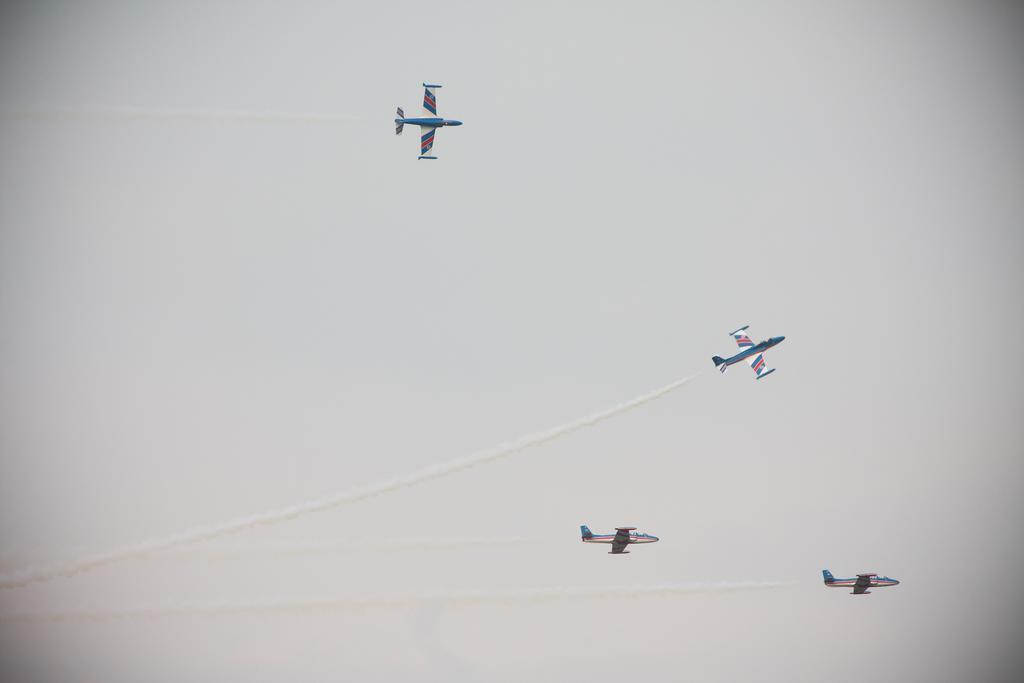How many airplanes are in the image? There are four airplanes in the image. What are the airplanes doing in the image? The airplanes are flying in the sky. What can be seen in the sky as a result of the airplanes' movement? There are contrails in the sky. What is visible in the background of the image? The sky is visible in the background of the image. What type of stem can be seen growing from the carriage in the image? There is no carriage or stem present in the image; it features four airplanes flying in the sky. 